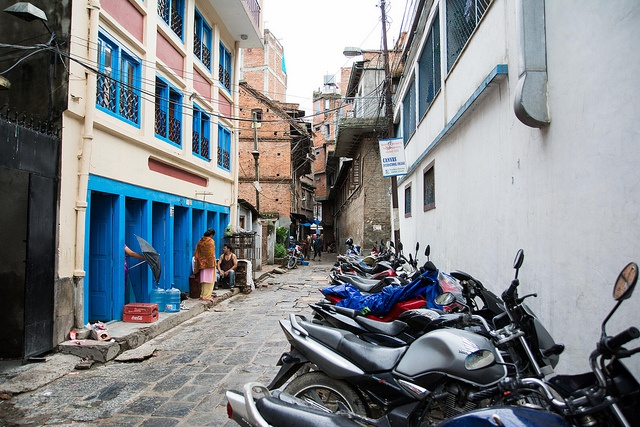Describe the objects in this image and their specific colors. I can see motorcycle in black, gray, darkgray, and lightgray tones, motorcycle in black, gray, darkgray, and navy tones, motorcycle in black, navy, darkgray, and gray tones, motorcycle in black, darkgray, lightgray, and gray tones, and people in black, maroon, lightpink, and brown tones in this image. 